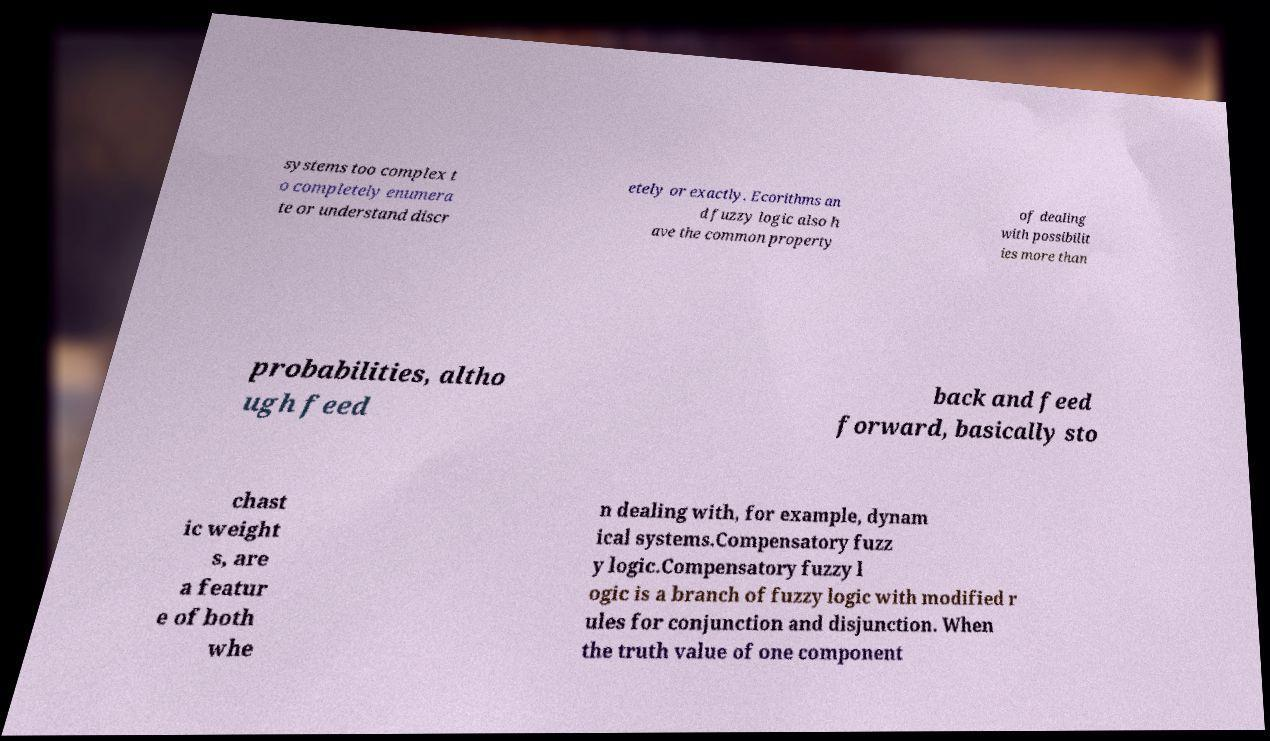Could you extract and type out the text from this image? systems too complex t o completely enumera te or understand discr etely or exactly. Ecorithms an d fuzzy logic also h ave the common property of dealing with possibilit ies more than probabilities, altho ugh feed back and feed forward, basically sto chast ic weight s, are a featur e of both whe n dealing with, for example, dynam ical systems.Compensatory fuzz y logic.Compensatory fuzzy l ogic is a branch of fuzzy logic with modified r ules for conjunction and disjunction. When the truth value of one component 